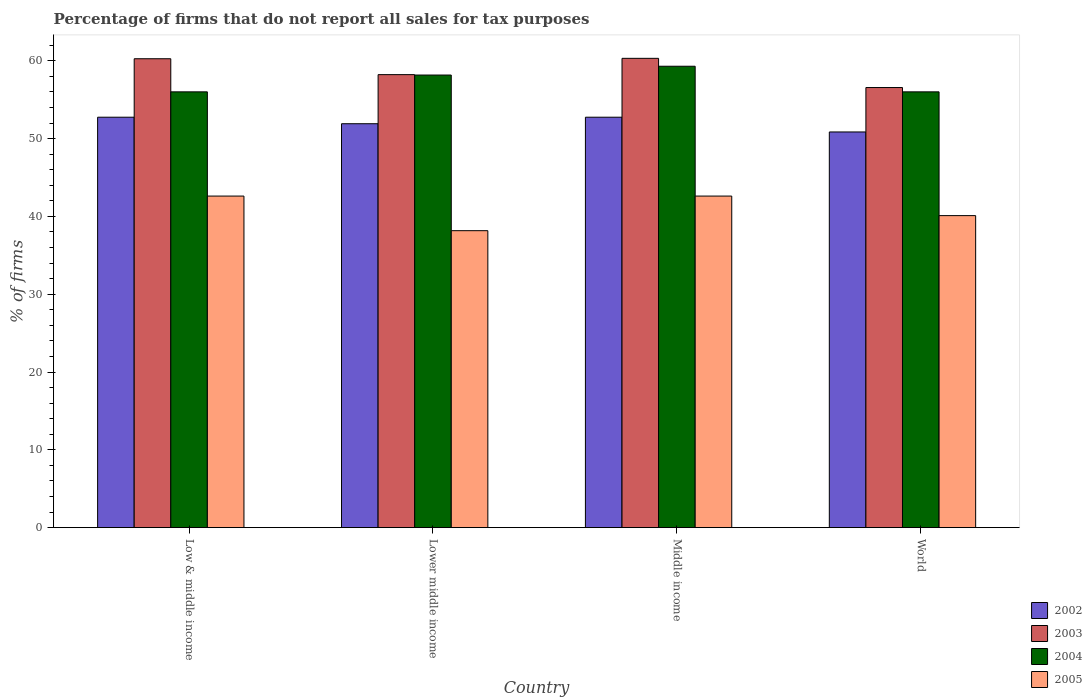How many groups of bars are there?
Your response must be concise. 4. Are the number of bars on each tick of the X-axis equal?
Offer a terse response. Yes. What is the percentage of firms that do not report all sales for tax purposes in 2002 in Middle income?
Keep it short and to the point. 52.75. Across all countries, what is the maximum percentage of firms that do not report all sales for tax purposes in 2003?
Offer a terse response. 60.31. Across all countries, what is the minimum percentage of firms that do not report all sales for tax purposes in 2003?
Offer a very short reply. 56.56. In which country was the percentage of firms that do not report all sales for tax purposes in 2005 maximum?
Make the answer very short. Low & middle income. In which country was the percentage of firms that do not report all sales for tax purposes in 2004 minimum?
Ensure brevity in your answer.  Low & middle income. What is the total percentage of firms that do not report all sales for tax purposes in 2004 in the graph?
Keep it short and to the point. 229.47. What is the difference between the percentage of firms that do not report all sales for tax purposes in 2003 in Low & middle income and the percentage of firms that do not report all sales for tax purposes in 2005 in Lower middle income?
Offer a very short reply. 22.1. What is the average percentage of firms that do not report all sales for tax purposes in 2005 per country?
Keep it short and to the point. 40.87. What is the difference between the percentage of firms that do not report all sales for tax purposes of/in 2003 and percentage of firms that do not report all sales for tax purposes of/in 2002 in Lower middle income?
Ensure brevity in your answer.  6.31. In how many countries, is the percentage of firms that do not report all sales for tax purposes in 2003 greater than 10 %?
Provide a short and direct response. 4. What is the ratio of the percentage of firms that do not report all sales for tax purposes in 2003 in Lower middle income to that in Middle income?
Offer a terse response. 0.97. Is the percentage of firms that do not report all sales for tax purposes in 2003 in Lower middle income less than that in World?
Offer a very short reply. No. Is the difference between the percentage of firms that do not report all sales for tax purposes in 2003 in Lower middle income and Middle income greater than the difference between the percentage of firms that do not report all sales for tax purposes in 2002 in Lower middle income and Middle income?
Provide a short and direct response. No. What is the difference between the highest and the second highest percentage of firms that do not report all sales for tax purposes in 2004?
Make the answer very short. -2.16. What is the difference between the highest and the lowest percentage of firms that do not report all sales for tax purposes in 2004?
Your answer should be very brief. 3.29. In how many countries, is the percentage of firms that do not report all sales for tax purposes in 2002 greater than the average percentage of firms that do not report all sales for tax purposes in 2002 taken over all countries?
Provide a succinct answer. 2. Is the sum of the percentage of firms that do not report all sales for tax purposes in 2005 in Low & middle income and Lower middle income greater than the maximum percentage of firms that do not report all sales for tax purposes in 2004 across all countries?
Offer a terse response. Yes. Is it the case that in every country, the sum of the percentage of firms that do not report all sales for tax purposes in 2004 and percentage of firms that do not report all sales for tax purposes in 2005 is greater than the percentage of firms that do not report all sales for tax purposes in 2003?
Your answer should be very brief. Yes. How many bars are there?
Your response must be concise. 16. Are all the bars in the graph horizontal?
Provide a short and direct response. No. What is the difference between two consecutive major ticks on the Y-axis?
Make the answer very short. 10. Are the values on the major ticks of Y-axis written in scientific E-notation?
Make the answer very short. No. Does the graph contain any zero values?
Provide a short and direct response. No. How are the legend labels stacked?
Provide a short and direct response. Vertical. What is the title of the graph?
Your answer should be compact. Percentage of firms that do not report all sales for tax purposes. What is the label or title of the Y-axis?
Your response must be concise. % of firms. What is the % of firms of 2002 in Low & middle income?
Your answer should be compact. 52.75. What is the % of firms in 2003 in Low & middle income?
Make the answer very short. 60.26. What is the % of firms in 2004 in Low & middle income?
Ensure brevity in your answer.  56.01. What is the % of firms of 2005 in Low & middle income?
Your response must be concise. 42.61. What is the % of firms in 2002 in Lower middle income?
Your answer should be very brief. 51.91. What is the % of firms in 2003 in Lower middle income?
Make the answer very short. 58.22. What is the % of firms of 2004 in Lower middle income?
Your answer should be very brief. 58.16. What is the % of firms in 2005 in Lower middle income?
Give a very brief answer. 38.16. What is the % of firms of 2002 in Middle income?
Make the answer very short. 52.75. What is the % of firms of 2003 in Middle income?
Offer a very short reply. 60.31. What is the % of firms in 2004 in Middle income?
Provide a succinct answer. 59.3. What is the % of firms in 2005 in Middle income?
Your answer should be compact. 42.61. What is the % of firms in 2002 in World?
Ensure brevity in your answer.  50.85. What is the % of firms in 2003 in World?
Your answer should be very brief. 56.56. What is the % of firms of 2004 in World?
Your response must be concise. 56.01. What is the % of firms in 2005 in World?
Keep it short and to the point. 40.1. Across all countries, what is the maximum % of firms in 2002?
Make the answer very short. 52.75. Across all countries, what is the maximum % of firms of 2003?
Provide a succinct answer. 60.31. Across all countries, what is the maximum % of firms of 2004?
Your answer should be compact. 59.3. Across all countries, what is the maximum % of firms in 2005?
Your answer should be very brief. 42.61. Across all countries, what is the minimum % of firms of 2002?
Your response must be concise. 50.85. Across all countries, what is the minimum % of firms of 2003?
Provide a succinct answer. 56.56. Across all countries, what is the minimum % of firms in 2004?
Give a very brief answer. 56.01. Across all countries, what is the minimum % of firms in 2005?
Make the answer very short. 38.16. What is the total % of firms of 2002 in the graph?
Make the answer very short. 208.25. What is the total % of firms in 2003 in the graph?
Keep it short and to the point. 235.35. What is the total % of firms of 2004 in the graph?
Offer a terse response. 229.47. What is the total % of firms of 2005 in the graph?
Keep it short and to the point. 163.48. What is the difference between the % of firms of 2002 in Low & middle income and that in Lower middle income?
Provide a short and direct response. 0.84. What is the difference between the % of firms of 2003 in Low & middle income and that in Lower middle income?
Offer a terse response. 2.04. What is the difference between the % of firms of 2004 in Low & middle income and that in Lower middle income?
Offer a very short reply. -2.16. What is the difference between the % of firms of 2005 in Low & middle income and that in Lower middle income?
Your answer should be compact. 4.45. What is the difference between the % of firms of 2002 in Low & middle income and that in Middle income?
Ensure brevity in your answer.  0. What is the difference between the % of firms in 2003 in Low & middle income and that in Middle income?
Your answer should be compact. -0.05. What is the difference between the % of firms in 2004 in Low & middle income and that in Middle income?
Make the answer very short. -3.29. What is the difference between the % of firms in 2002 in Low & middle income and that in World?
Offer a very short reply. 1.89. What is the difference between the % of firms of 2004 in Low & middle income and that in World?
Give a very brief answer. 0. What is the difference between the % of firms of 2005 in Low & middle income and that in World?
Your response must be concise. 2.51. What is the difference between the % of firms in 2002 in Lower middle income and that in Middle income?
Give a very brief answer. -0.84. What is the difference between the % of firms of 2003 in Lower middle income and that in Middle income?
Your answer should be very brief. -2.09. What is the difference between the % of firms in 2004 in Lower middle income and that in Middle income?
Ensure brevity in your answer.  -1.13. What is the difference between the % of firms of 2005 in Lower middle income and that in Middle income?
Provide a succinct answer. -4.45. What is the difference between the % of firms in 2002 in Lower middle income and that in World?
Your answer should be compact. 1.06. What is the difference between the % of firms of 2003 in Lower middle income and that in World?
Your answer should be very brief. 1.66. What is the difference between the % of firms in 2004 in Lower middle income and that in World?
Offer a terse response. 2.16. What is the difference between the % of firms of 2005 in Lower middle income and that in World?
Your answer should be compact. -1.94. What is the difference between the % of firms in 2002 in Middle income and that in World?
Provide a succinct answer. 1.89. What is the difference between the % of firms in 2003 in Middle income and that in World?
Make the answer very short. 3.75. What is the difference between the % of firms of 2004 in Middle income and that in World?
Offer a very short reply. 3.29. What is the difference between the % of firms in 2005 in Middle income and that in World?
Keep it short and to the point. 2.51. What is the difference between the % of firms of 2002 in Low & middle income and the % of firms of 2003 in Lower middle income?
Provide a succinct answer. -5.47. What is the difference between the % of firms of 2002 in Low & middle income and the % of firms of 2004 in Lower middle income?
Offer a very short reply. -5.42. What is the difference between the % of firms in 2002 in Low & middle income and the % of firms in 2005 in Lower middle income?
Your response must be concise. 14.58. What is the difference between the % of firms in 2003 in Low & middle income and the % of firms in 2004 in Lower middle income?
Provide a short and direct response. 2.1. What is the difference between the % of firms of 2003 in Low & middle income and the % of firms of 2005 in Lower middle income?
Provide a short and direct response. 22.1. What is the difference between the % of firms of 2004 in Low & middle income and the % of firms of 2005 in Lower middle income?
Provide a succinct answer. 17.84. What is the difference between the % of firms in 2002 in Low & middle income and the % of firms in 2003 in Middle income?
Offer a terse response. -7.57. What is the difference between the % of firms of 2002 in Low & middle income and the % of firms of 2004 in Middle income?
Your response must be concise. -6.55. What is the difference between the % of firms of 2002 in Low & middle income and the % of firms of 2005 in Middle income?
Make the answer very short. 10.13. What is the difference between the % of firms in 2003 in Low & middle income and the % of firms in 2005 in Middle income?
Your response must be concise. 17.65. What is the difference between the % of firms in 2004 in Low & middle income and the % of firms in 2005 in Middle income?
Offer a very short reply. 13.39. What is the difference between the % of firms of 2002 in Low & middle income and the % of firms of 2003 in World?
Provide a succinct answer. -3.81. What is the difference between the % of firms of 2002 in Low & middle income and the % of firms of 2004 in World?
Provide a succinct answer. -3.26. What is the difference between the % of firms in 2002 in Low & middle income and the % of firms in 2005 in World?
Offer a terse response. 12.65. What is the difference between the % of firms in 2003 in Low & middle income and the % of firms in 2004 in World?
Ensure brevity in your answer.  4.25. What is the difference between the % of firms in 2003 in Low & middle income and the % of firms in 2005 in World?
Offer a very short reply. 20.16. What is the difference between the % of firms of 2004 in Low & middle income and the % of firms of 2005 in World?
Ensure brevity in your answer.  15.91. What is the difference between the % of firms in 2002 in Lower middle income and the % of firms in 2003 in Middle income?
Your response must be concise. -8.4. What is the difference between the % of firms in 2002 in Lower middle income and the % of firms in 2004 in Middle income?
Your response must be concise. -7.39. What is the difference between the % of firms of 2002 in Lower middle income and the % of firms of 2005 in Middle income?
Your response must be concise. 9.3. What is the difference between the % of firms of 2003 in Lower middle income and the % of firms of 2004 in Middle income?
Your answer should be compact. -1.08. What is the difference between the % of firms in 2003 in Lower middle income and the % of firms in 2005 in Middle income?
Your response must be concise. 15.61. What is the difference between the % of firms in 2004 in Lower middle income and the % of firms in 2005 in Middle income?
Make the answer very short. 15.55. What is the difference between the % of firms in 2002 in Lower middle income and the % of firms in 2003 in World?
Provide a short and direct response. -4.65. What is the difference between the % of firms in 2002 in Lower middle income and the % of firms in 2004 in World?
Your response must be concise. -4.1. What is the difference between the % of firms in 2002 in Lower middle income and the % of firms in 2005 in World?
Ensure brevity in your answer.  11.81. What is the difference between the % of firms of 2003 in Lower middle income and the % of firms of 2004 in World?
Give a very brief answer. 2.21. What is the difference between the % of firms of 2003 in Lower middle income and the % of firms of 2005 in World?
Your response must be concise. 18.12. What is the difference between the % of firms of 2004 in Lower middle income and the % of firms of 2005 in World?
Your answer should be compact. 18.07. What is the difference between the % of firms in 2002 in Middle income and the % of firms in 2003 in World?
Your response must be concise. -3.81. What is the difference between the % of firms of 2002 in Middle income and the % of firms of 2004 in World?
Provide a short and direct response. -3.26. What is the difference between the % of firms of 2002 in Middle income and the % of firms of 2005 in World?
Make the answer very short. 12.65. What is the difference between the % of firms of 2003 in Middle income and the % of firms of 2004 in World?
Keep it short and to the point. 4.31. What is the difference between the % of firms of 2003 in Middle income and the % of firms of 2005 in World?
Provide a short and direct response. 20.21. What is the difference between the % of firms in 2004 in Middle income and the % of firms in 2005 in World?
Keep it short and to the point. 19.2. What is the average % of firms in 2002 per country?
Your response must be concise. 52.06. What is the average % of firms in 2003 per country?
Provide a succinct answer. 58.84. What is the average % of firms in 2004 per country?
Offer a very short reply. 57.37. What is the average % of firms in 2005 per country?
Give a very brief answer. 40.87. What is the difference between the % of firms of 2002 and % of firms of 2003 in Low & middle income?
Ensure brevity in your answer.  -7.51. What is the difference between the % of firms of 2002 and % of firms of 2004 in Low & middle income?
Your response must be concise. -3.26. What is the difference between the % of firms in 2002 and % of firms in 2005 in Low & middle income?
Provide a short and direct response. 10.13. What is the difference between the % of firms of 2003 and % of firms of 2004 in Low & middle income?
Keep it short and to the point. 4.25. What is the difference between the % of firms in 2003 and % of firms in 2005 in Low & middle income?
Your answer should be compact. 17.65. What is the difference between the % of firms of 2004 and % of firms of 2005 in Low & middle income?
Your answer should be compact. 13.39. What is the difference between the % of firms in 2002 and % of firms in 2003 in Lower middle income?
Give a very brief answer. -6.31. What is the difference between the % of firms of 2002 and % of firms of 2004 in Lower middle income?
Offer a terse response. -6.26. What is the difference between the % of firms in 2002 and % of firms in 2005 in Lower middle income?
Ensure brevity in your answer.  13.75. What is the difference between the % of firms of 2003 and % of firms of 2004 in Lower middle income?
Your answer should be compact. 0.05. What is the difference between the % of firms in 2003 and % of firms in 2005 in Lower middle income?
Your response must be concise. 20.06. What is the difference between the % of firms in 2004 and % of firms in 2005 in Lower middle income?
Give a very brief answer. 20. What is the difference between the % of firms in 2002 and % of firms in 2003 in Middle income?
Provide a succinct answer. -7.57. What is the difference between the % of firms in 2002 and % of firms in 2004 in Middle income?
Ensure brevity in your answer.  -6.55. What is the difference between the % of firms in 2002 and % of firms in 2005 in Middle income?
Your answer should be very brief. 10.13. What is the difference between the % of firms of 2003 and % of firms of 2004 in Middle income?
Offer a very short reply. 1.02. What is the difference between the % of firms of 2003 and % of firms of 2005 in Middle income?
Offer a very short reply. 17.7. What is the difference between the % of firms in 2004 and % of firms in 2005 in Middle income?
Give a very brief answer. 16.69. What is the difference between the % of firms in 2002 and % of firms in 2003 in World?
Give a very brief answer. -5.71. What is the difference between the % of firms of 2002 and % of firms of 2004 in World?
Provide a short and direct response. -5.15. What is the difference between the % of firms of 2002 and % of firms of 2005 in World?
Your response must be concise. 10.75. What is the difference between the % of firms of 2003 and % of firms of 2004 in World?
Your response must be concise. 0.56. What is the difference between the % of firms in 2003 and % of firms in 2005 in World?
Your answer should be compact. 16.46. What is the difference between the % of firms in 2004 and % of firms in 2005 in World?
Your response must be concise. 15.91. What is the ratio of the % of firms of 2002 in Low & middle income to that in Lower middle income?
Your response must be concise. 1.02. What is the ratio of the % of firms in 2003 in Low & middle income to that in Lower middle income?
Keep it short and to the point. 1.04. What is the ratio of the % of firms of 2004 in Low & middle income to that in Lower middle income?
Provide a short and direct response. 0.96. What is the ratio of the % of firms in 2005 in Low & middle income to that in Lower middle income?
Your response must be concise. 1.12. What is the ratio of the % of firms in 2003 in Low & middle income to that in Middle income?
Your answer should be compact. 1. What is the ratio of the % of firms in 2004 in Low & middle income to that in Middle income?
Ensure brevity in your answer.  0.94. What is the ratio of the % of firms of 2005 in Low & middle income to that in Middle income?
Offer a terse response. 1. What is the ratio of the % of firms in 2002 in Low & middle income to that in World?
Your answer should be compact. 1.04. What is the ratio of the % of firms in 2003 in Low & middle income to that in World?
Ensure brevity in your answer.  1.07. What is the ratio of the % of firms of 2004 in Low & middle income to that in World?
Provide a short and direct response. 1. What is the ratio of the % of firms in 2005 in Low & middle income to that in World?
Ensure brevity in your answer.  1.06. What is the ratio of the % of firms in 2002 in Lower middle income to that in Middle income?
Your response must be concise. 0.98. What is the ratio of the % of firms of 2003 in Lower middle income to that in Middle income?
Offer a very short reply. 0.97. What is the ratio of the % of firms in 2004 in Lower middle income to that in Middle income?
Offer a very short reply. 0.98. What is the ratio of the % of firms of 2005 in Lower middle income to that in Middle income?
Give a very brief answer. 0.9. What is the ratio of the % of firms of 2002 in Lower middle income to that in World?
Give a very brief answer. 1.02. What is the ratio of the % of firms in 2003 in Lower middle income to that in World?
Make the answer very short. 1.03. What is the ratio of the % of firms of 2004 in Lower middle income to that in World?
Provide a short and direct response. 1.04. What is the ratio of the % of firms in 2005 in Lower middle income to that in World?
Provide a succinct answer. 0.95. What is the ratio of the % of firms of 2002 in Middle income to that in World?
Your response must be concise. 1.04. What is the ratio of the % of firms of 2003 in Middle income to that in World?
Keep it short and to the point. 1.07. What is the ratio of the % of firms of 2004 in Middle income to that in World?
Your answer should be very brief. 1.06. What is the ratio of the % of firms of 2005 in Middle income to that in World?
Offer a terse response. 1.06. What is the difference between the highest and the second highest % of firms in 2002?
Provide a short and direct response. 0. What is the difference between the highest and the second highest % of firms in 2003?
Give a very brief answer. 0.05. What is the difference between the highest and the second highest % of firms in 2004?
Offer a very short reply. 1.13. What is the difference between the highest and the lowest % of firms of 2002?
Offer a very short reply. 1.89. What is the difference between the highest and the lowest % of firms in 2003?
Give a very brief answer. 3.75. What is the difference between the highest and the lowest % of firms in 2004?
Offer a terse response. 3.29. What is the difference between the highest and the lowest % of firms in 2005?
Provide a succinct answer. 4.45. 